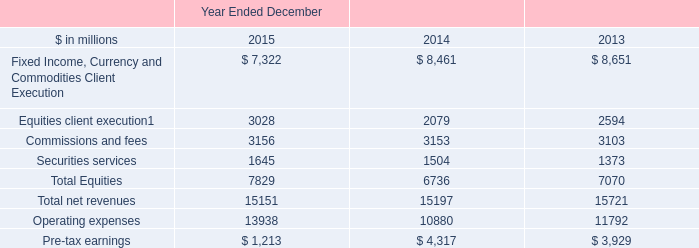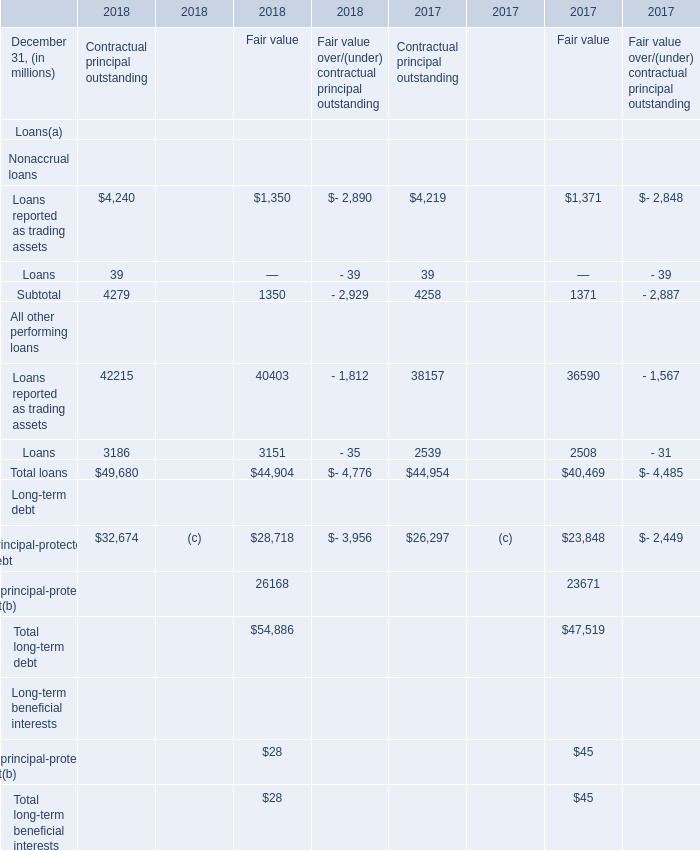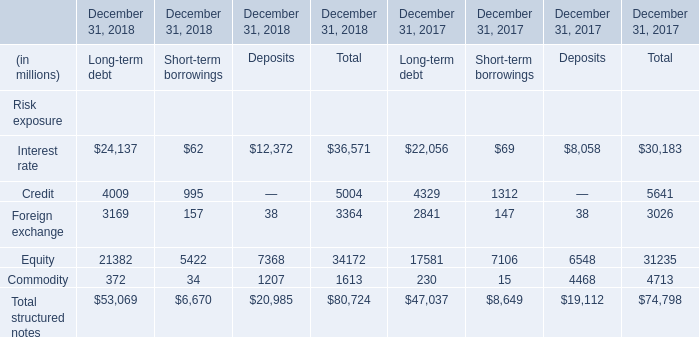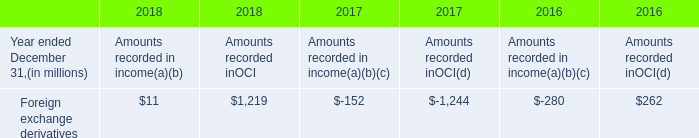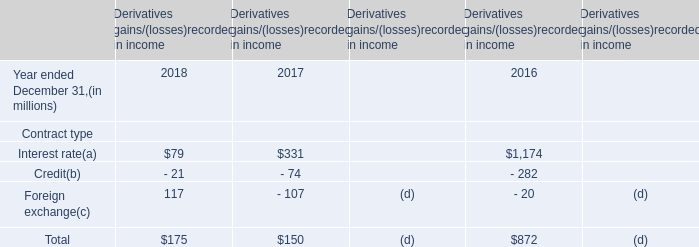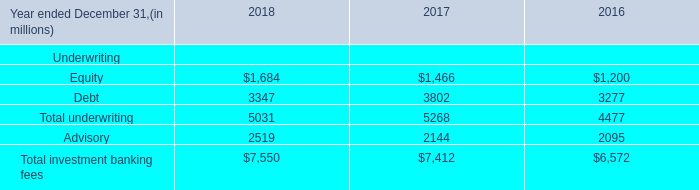What's the increasing rate of Equity for Total in 2018? 
Computations: ((34172 - 31235) / 31235)
Answer: 0.09403. 